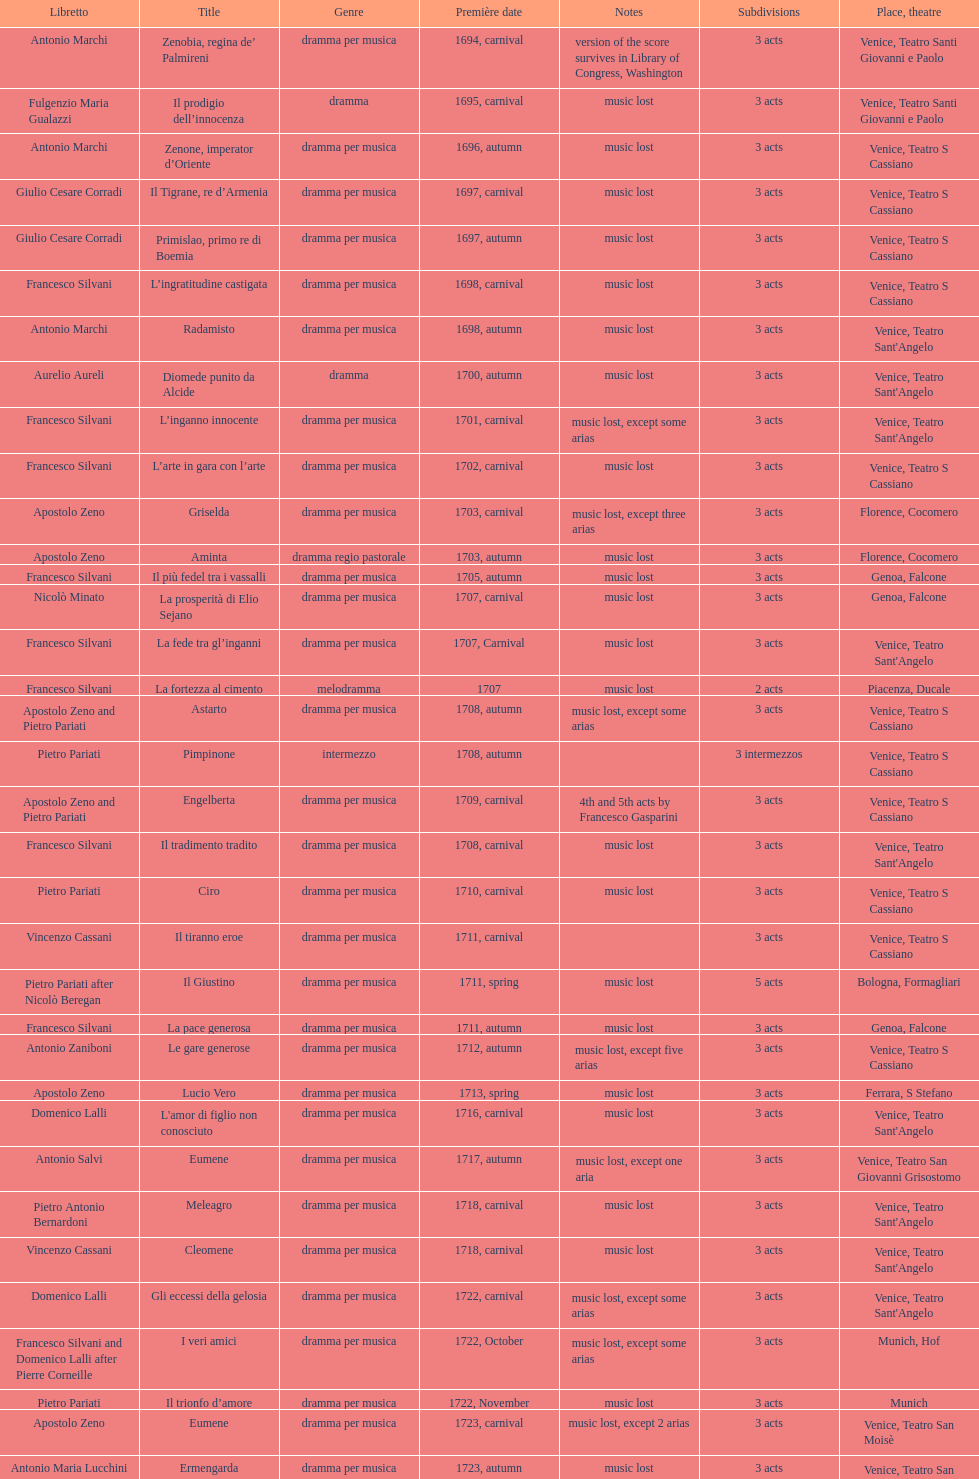How many were released after zenone, imperator d'oriente? 52. 